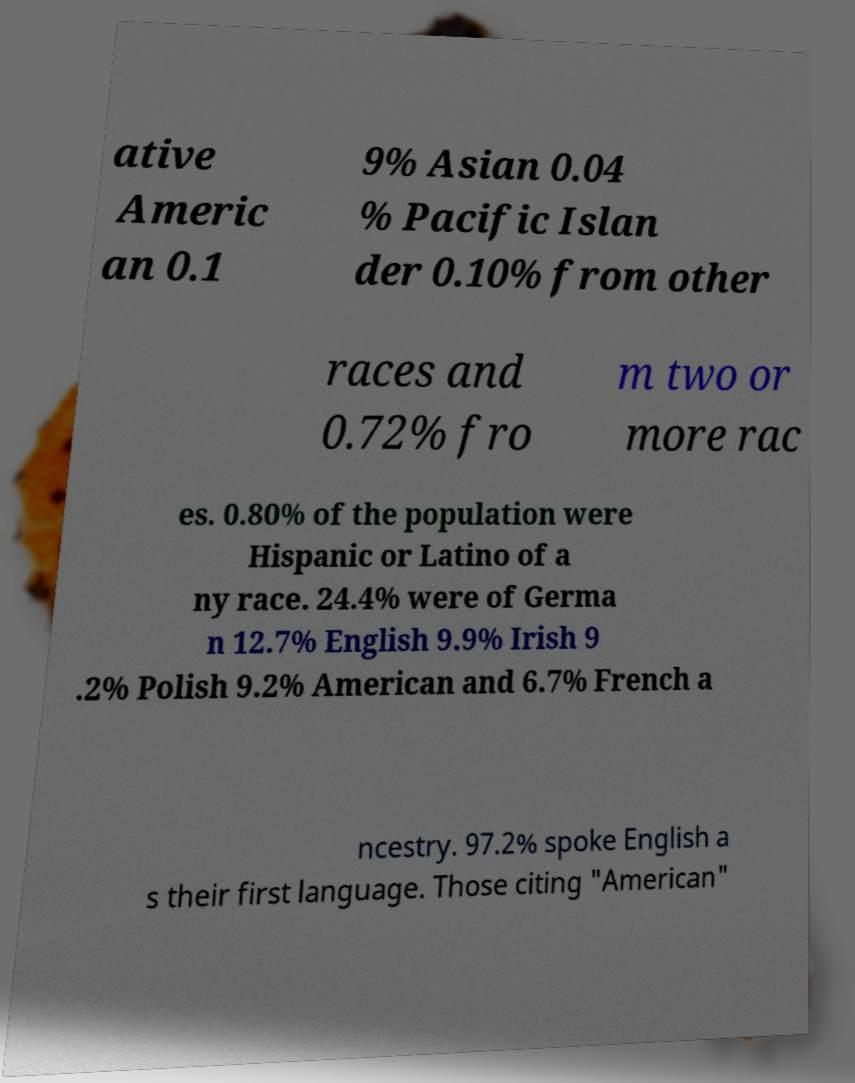Could you assist in decoding the text presented in this image and type it out clearly? ative Americ an 0.1 9% Asian 0.04 % Pacific Islan der 0.10% from other races and 0.72% fro m two or more rac es. 0.80% of the population were Hispanic or Latino of a ny race. 24.4% were of Germa n 12.7% English 9.9% Irish 9 .2% Polish 9.2% American and 6.7% French a ncestry. 97.2% spoke English a s their first language. Those citing "American" 